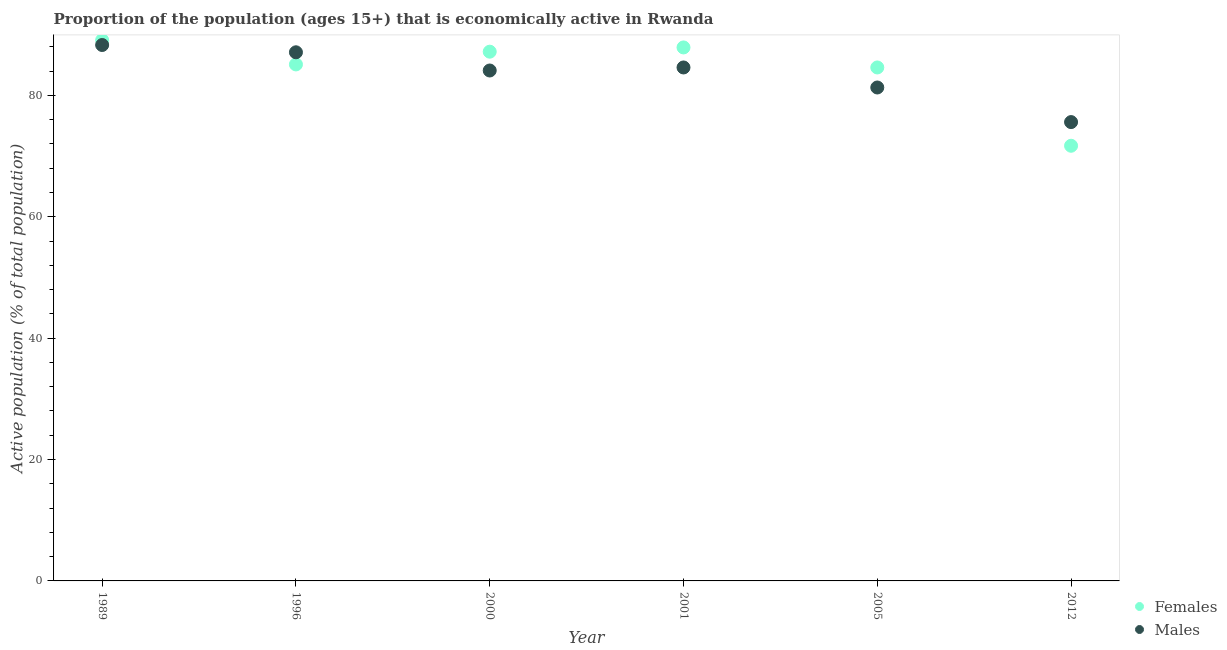How many different coloured dotlines are there?
Make the answer very short. 2. What is the percentage of economically active male population in 2012?
Your response must be concise. 75.6. Across all years, what is the maximum percentage of economically active female population?
Offer a terse response. 89.1. Across all years, what is the minimum percentage of economically active female population?
Make the answer very short. 71.7. In which year was the percentage of economically active female population maximum?
Provide a succinct answer. 1989. What is the total percentage of economically active male population in the graph?
Your response must be concise. 501. What is the difference between the percentage of economically active female population in 2001 and that in 2005?
Ensure brevity in your answer.  3.3. What is the difference between the percentage of economically active female population in 1996 and the percentage of economically active male population in 2005?
Offer a very short reply. 3.8. What is the average percentage of economically active male population per year?
Provide a succinct answer. 83.5. In the year 1989, what is the difference between the percentage of economically active male population and percentage of economically active female population?
Your response must be concise. -0.8. What is the ratio of the percentage of economically active female population in 1989 to that in 2001?
Your answer should be compact. 1.01. What is the difference between the highest and the second highest percentage of economically active female population?
Keep it short and to the point. 1.2. What is the difference between the highest and the lowest percentage of economically active male population?
Your response must be concise. 12.7. In how many years, is the percentage of economically active male population greater than the average percentage of economically active male population taken over all years?
Offer a very short reply. 4. Is the sum of the percentage of economically active female population in 2000 and 2005 greater than the maximum percentage of economically active male population across all years?
Ensure brevity in your answer.  Yes. Are the values on the major ticks of Y-axis written in scientific E-notation?
Offer a terse response. No. How many legend labels are there?
Give a very brief answer. 2. How are the legend labels stacked?
Ensure brevity in your answer.  Vertical. What is the title of the graph?
Provide a short and direct response. Proportion of the population (ages 15+) that is economically active in Rwanda. Does "Primary school" appear as one of the legend labels in the graph?
Ensure brevity in your answer.  No. What is the label or title of the Y-axis?
Provide a succinct answer. Active population (% of total population). What is the Active population (% of total population) of Females in 1989?
Give a very brief answer. 89.1. What is the Active population (% of total population) in Males in 1989?
Your answer should be compact. 88.3. What is the Active population (% of total population) in Females in 1996?
Your response must be concise. 85.1. What is the Active population (% of total population) in Males in 1996?
Your response must be concise. 87.1. What is the Active population (% of total population) of Females in 2000?
Ensure brevity in your answer.  87.2. What is the Active population (% of total population) of Males in 2000?
Provide a short and direct response. 84.1. What is the Active population (% of total population) in Females in 2001?
Provide a succinct answer. 87.9. What is the Active population (% of total population) of Males in 2001?
Give a very brief answer. 84.6. What is the Active population (% of total population) in Females in 2005?
Make the answer very short. 84.6. What is the Active population (% of total population) of Males in 2005?
Keep it short and to the point. 81.3. What is the Active population (% of total population) in Females in 2012?
Keep it short and to the point. 71.7. What is the Active population (% of total population) of Males in 2012?
Make the answer very short. 75.6. Across all years, what is the maximum Active population (% of total population) in Females?
Offer a terse response. 89.1. Across all years, what is the maximum Active population (% of total population) of Males?
Provide a succinct answer. 88.3. Across all years, what is the minimum Active population (% of total population) of Females?
Provide a succinct answer. 71.7. Across all years, what is the minimum Active population (% of total population) in Males?
Your answer should be compact. 75.6. What is the total Active population (% of total population) in Females in the graph?
Your answer should be very brief. 505.6. What is the total Active population (% of total population) in Males in the graph?
Offer a terse response. 501. What is the difference between the Active population (% of total population) in Females in 1989 and that in 1996?
Your response must be concise. 4. What is the difference between the Active population (% of total population) in Males in 1989 and that in 2000?
Give a very brief answer. 4.2. What is the difference between the Active population (% of total population) of Males in 1989 and that in 2005?
Your response must be concise. 7. What is the difference between the Active population (% of total population) of Females in 1989 and that in 2012?
Keep it short and to the point. 17.4. What is the difference between the Active population (% of total population) of Females in 1996 and that in 2000?
Ensure brevity in your answer.  -2.1. What is the difference between the Active population (% of total population) in Females in 1996 and that in 2001?
Your answer should be very brief. -2.8. What is the difference between the Active population (% of total population) in Males in 1996 and that in 2005?
Keep it short and to the point. 5.8. What is the difference between the Active population (% of total population) of Females in 1996 and that in 2012?
Your response must be concise. 13.4. What is the difference between the Active population (% of total population) of Females in 2000 and that in 2001?
Your response must be concise. -0.7. What is the difference between the Active population (% of total population) of Males in 2000 and that in 2005?
Make the answer very short. 2.8. What is the difference between the Active population (% of total population) in Females in 2001 and that in 2005?
Make the answer very short. 3.3. What is the difference between the Active population (% of total population) of Males in 2001 and that in 2005?
Offer a very short reply. 3.3. What is the difference between the Active population (% of total population) of Females in 2001 and that in 2012?
Offer a terse response. 16.2. What is the difference between the Active population (% of total population) in Males in 2001 and that in 2012?
Your response must be concise. 9. What is the difference between the Active population (% of total population) in Females in 2005 and that in 2012?
Provide a succinct answer. 12.9. What is the difference between the Active population (% of total population) of Females in 1989 and the Active population (% of total population) of Males in 2001?
Provide a succinct answer. 4.5. What is the difference between the Active population (% of total population) in Females in 1989 and the Active population (% of total population) in Males in 2005?
Your answer should be compact. 7.8. What is the difference between the Active population (% of total population) of Females in 1996 and the Active population (% of total population) of Males in 2000?
Provide a short and direct response. 1. What is the difference between the Active population (% of total population) of Females in 1996 and the Active population (% of total population) of Males in 2012?
Ensure brevity in your answer.  9.5. What is the difference between the Active population (% of total population) of Females in 2000 and the Active population (% of total population) of Males in 2001?
Your answer should be compact. 2.6. What is the difference between the Active population (% of total population) of Females in 2000 and the Active population (% of total population) of Males in 2005?
Make the answer very short. 5.9. What is the difference between the Active population (% of total population) in Females in 2001 and the Active population (% of total population) in Males in 2005?
Your answer should be compact. 6.6. What is the average Active population (% of total population) in Females per year?
Provide a short and direct response. 84.27. What is the average Active population (% of total population) of Males per year?
Ensure brevity in your answer.  83.5. In the year 2000, what is the difference between the Active population (% of total population) of Females and Active population (% of total population) of Males?
Keep it short and to the point. 3.1. In the year 2001, what is the difference between the Active population (% of total population) in Females and Active population (% of total population) in Males?
Offer a terse response. 3.3. In the year 2005, what is the difference between the Active population (% of total population) of Females and Active population (% of total population) of Males?
Offer a terse response. 3.3. What is the ratio of the Active population (% of total population) in Females in 1989 to that in 1996?
Offer a terse response. 1.05. What is the ratio of the Active population (% of total population) of Males in 1989 to that in 1996?
Provide a succinct answer. 1.01. What is the ratio of the Active population (% of total population) of Females in 1989 to that in 2000?
Provide a short and direct response. 1.02. What is the ratio of the Active population (% of total population) in Males in 1989 to that in 2000?
Keep it short and to the point. 1.05. What is the ratio of the Active population (% of total population) of Females in 1989 to that in 2001?
Keep it short and to the point. 1.01. What is the ratio of the Active population (% of total population) of Males in 1989 to that in 2001?
Make the answer very short. 1.04. What is the ratio of the Active population (% of total population) of Females in 1989 to that in 2005?
Provide a short and direct response. 1.05. What is the ratio of the Active population (% of total population) of Males in 1989 to that in 2005?
Keep it short and to the point. 1.09. What is the ratio of the Active population (% of total population) of Females in 1989 to that in 2012?
Provide a short and direct response. 1.24. What is the ratio of the Active population (% of total population) of Males in 1989 to that in 2012?
Give a very brief answer. 1.17. What is the ratio of the Active population (% of total population) of Females in 1996 to that in 2000?
Provide a short and direct response. 0.98. What is the ratio of the Active population (% of total population) in Males in 1996 to that in 2000?
Offer a terse response. 1.04. What is the ratio of the Active population (% of total population) of Females in 1996 to that in 2001?
Offer a terse response. 0.97. What is the ratio of the Active population (% of total population) in Males in 1996 to that in 2001?
Your response must be concise. 1.03. What is the ratio of the Active population (% of total population) in Females in 1996 to that in 2005?
Provide a succinct answer. 1.01. What is the ratio of the Active population (% of total population) of Males in 1996 to that in 2005?
Provide a short and direct response. 1.07. What is the ratio of the Active population (% of total population) of Females in 1996 to that in 2012?
Keep it short and to the point. 1.19. What is the ratio of the Active population (% of total population) of Males in 1996 to that in 2012?
Offer a very short reply. 1.15. What is the ratio of the Active population (% of total population) in Females in 2000 to that in 2005?
Provide a short and direct response. 1.03. What is the ratio of the Active population (% of total population) in Males in 2000 to that in 2005?
Make the answer very short. 1.03. What is the ratio of the Active population (% of total population) of Females in 2000 to that in 2012?
Keep it short and to the point. 1.22. What is the ratio of the Active population (% of total population) in Males in 2000 to that in 2012?
Make the answer very short. 1.11. What is the ratio of the Active population (% of total population) in Females in 2001 to that in 2005?
Provide a succinct answer. 1.04. What is the ratio of the Active population (% of total population) in Males in 2001 to that in 2005?
Give a very brief answer. 1.04. What is the ratio of the Active population (% of total population) in Females in 2001 to that in 2012?
Your response must be concise. 1.23. What is the ratio of the Active population (% of total population) of Males in 2001 to that in 2012?
Your answer should be compact. 1.12. What is the ratio of the Active population (% of total population) in Females in 2005 to that in 2012?
Your answer should be compact. 1.18. What is the ratio of the Active population (% of total population) in Males in 2005 to that in 2012?
Give a very brief answer. 1.08. What is the difference between the highest and the second highest Active population (% of total population) of Males?
Keep it short and to the point. 1.2. What is the difference between the highest and the lowest Active population (% of total population) of Females?
Offer a very short reply. 17.4. What is the difference between the highest and the lowest Active population (% of total population) of Males?
Offer a terse response. 12.7. 